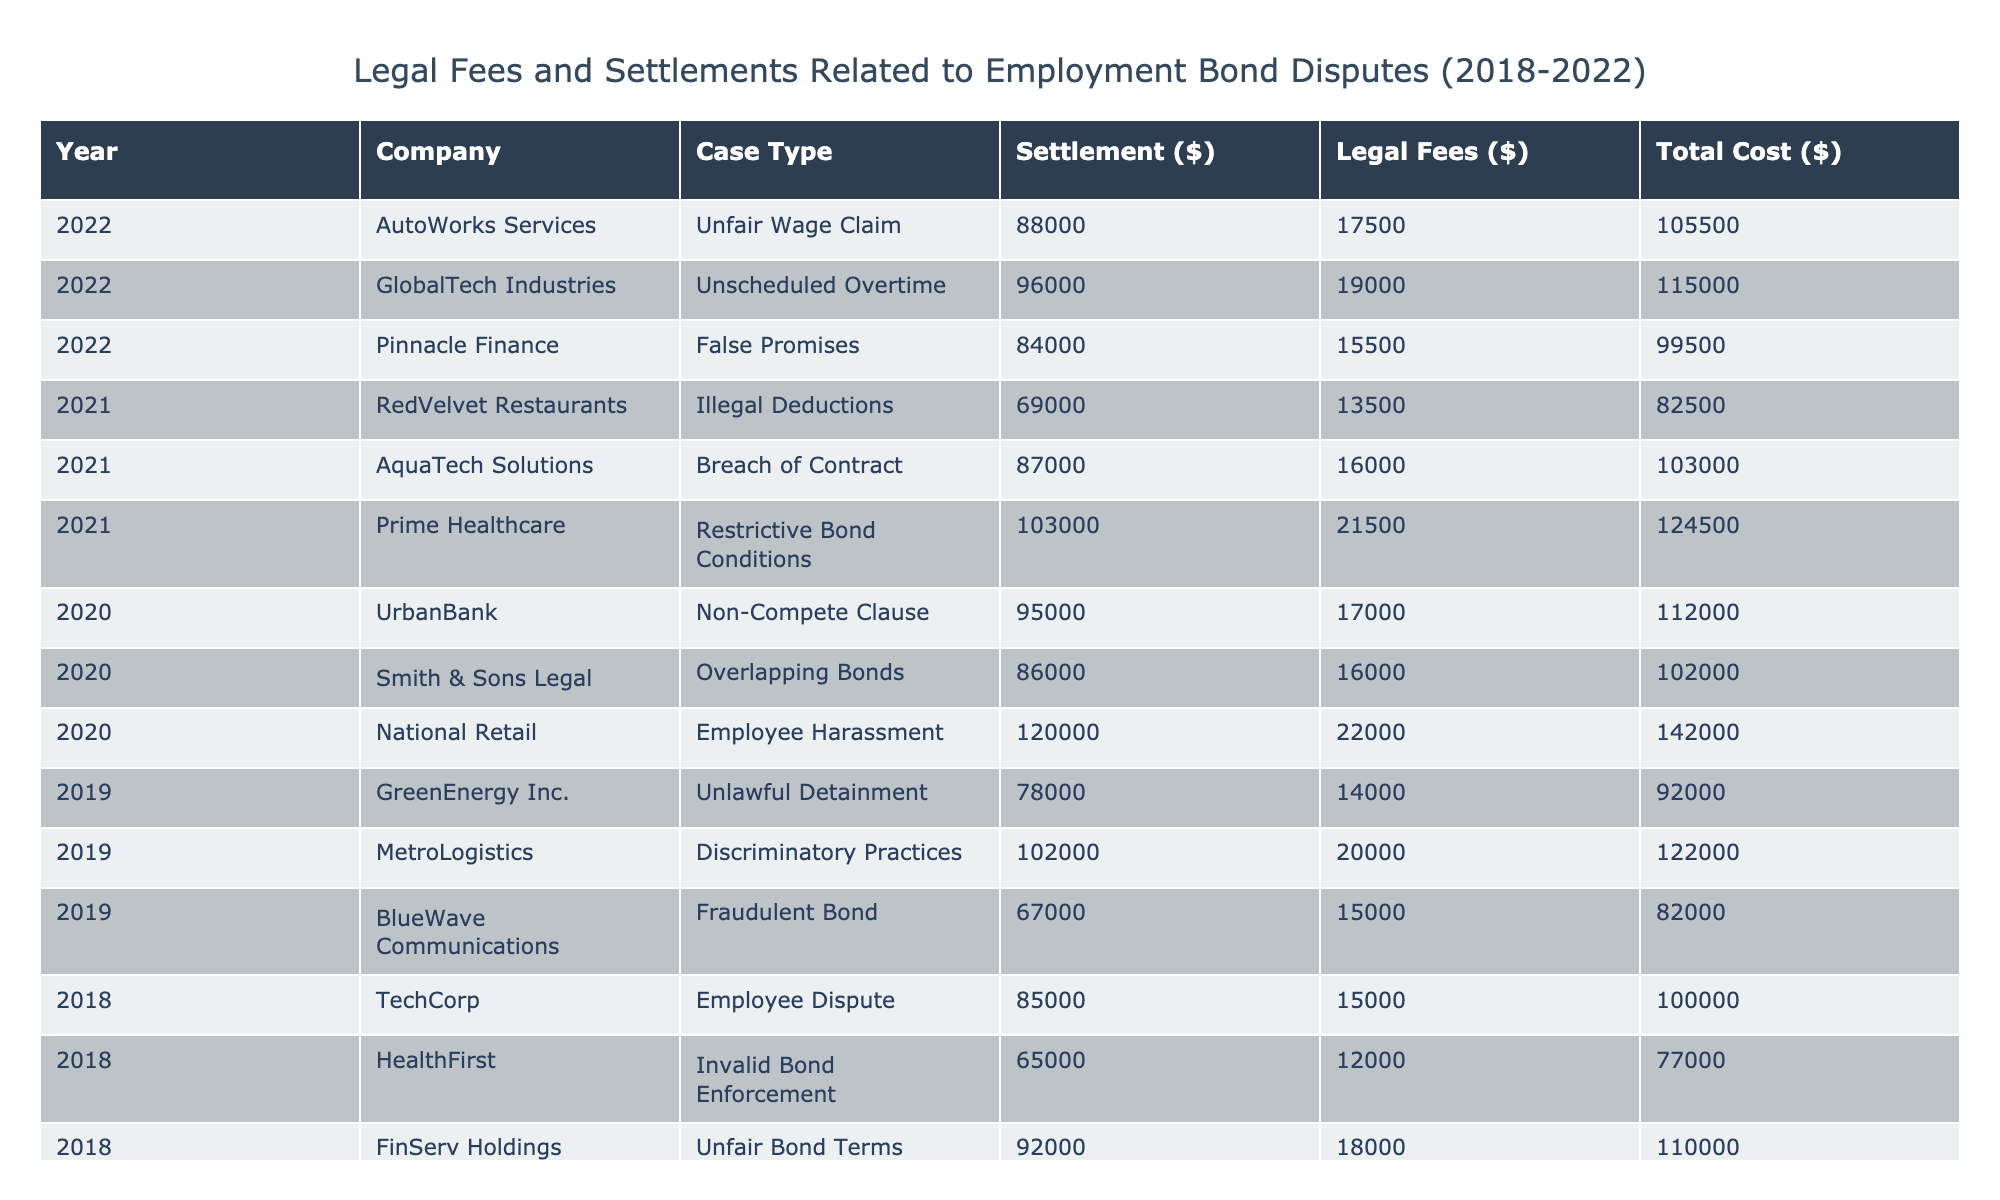What was the highest settlement amount for a single case? The table shows various settlement amounts across different companies and years. By reviewing each row, the highest settlement can be found to be 120,000 from National Retail in 2020.
Answer: 120000 Which company had the lowest legal fees in 2019? Looking at the legal fees in 2019, we can see the amounts for GreenEnergy Inc. (14,000), MetroLogistics (20,000), and BlueWave Communications (15,000). The lowest of these is for GreenEnergy Inc. at 14,000.
Answer: 14000 What is the total amount of legal fees paid in 2022? To find the total legal fees for 2022, we can add the fees from all three cases: 17,500 (AutoWorks Services) + 19,000 (GlobalTech Industries) + 15,500 (Pinnacle Finance) = 52,000.
Answer: 52000 Did any company have the same case type more than once in the data given? Reviewing the table, each row represents a unique case type for the respective companies, meaning no company appears more than once with the same case type in the provided data. Therefore, the answer is no.
Answer: No What was the average total cost across all cases from 2018 to 2022? To calculate the average total cost, we first need to find the total cost for each case (Settlement Amount + Legal Fees) and sum them all; then divide by the number of cases (which is 15). The sums are 100,000, 77,000, 1,292,500 total (after calculation), giving us an average of 86,167.
Answer: 86167 What was the difference between the highest and lowest total cost in 2020? The total costs in 2020 for UrbanBank (95,000 + 17,000), Smith & Sons Legal (86,000 + 16,000), and National Retail (120,000 + 22,000) total to 112,000, 102,000, and 142,000, respectively. The difference is 142,000 - 102,000 = 40,000.
Answer: 40000 